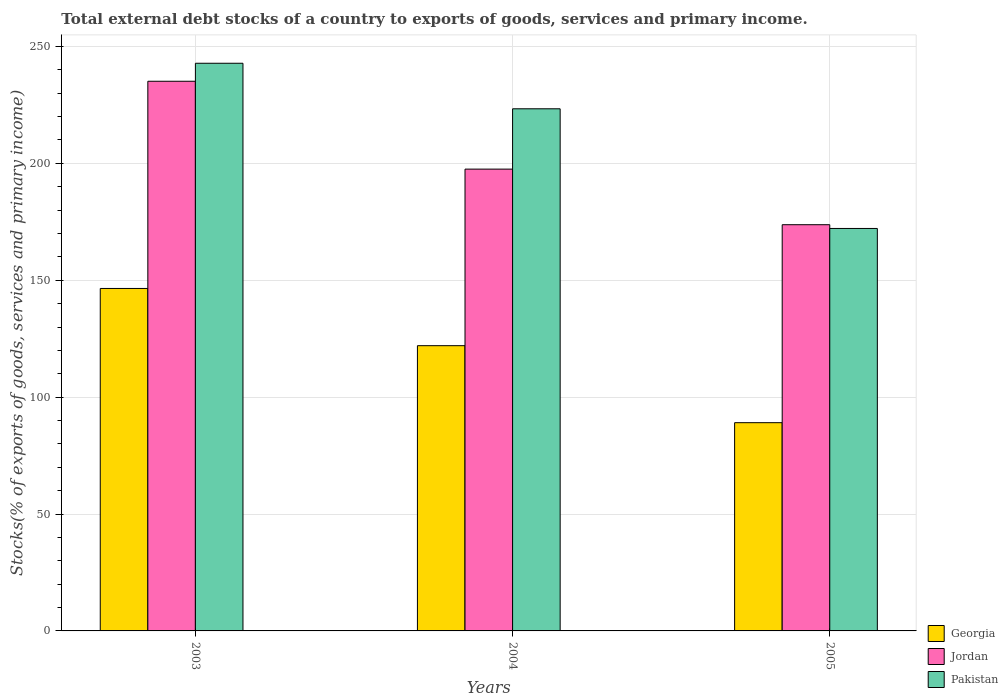How many different coloured bars are there?
Ensure brevity in your answer.  3. How many bars are there on the 1st tick from the right?
Ensure brevity in your answer.  3. What is the label of the 2nd group of bars from the left?
Your response must be concise. 2004. What is the total debt stocks in Georgia in 2003?
Give a very brief answer. 146.49. Across all years, what is the maximum total debt stocks in Jordan?
Your answer should be very brief. 235.12. Across all years, what is the minimum total debt stocks in Georgia?
Your answer should be very brief. 89.07. In which year was the total debt stocks in Pakistan maximum?
Make the answer very short. 2003. In which year was the total debt stocks in Pakistan minimum?
Give a very brief answer. 2005. What is the total total debt stocks in Georgia in the graph?
Your answer should be very brief. 357.58. What is the difference between the total debt stocks in Jordan in 2003 and that in 2005?
Your answer should be very brief. 61.36. What is the difference between the total debt stocks in Pakistan in 2005 and the total debt stocks in Jordan in 2004?
Keep it short and to the point. -25.38. What is the average total debt stocks in Pakistan per year?
Provide a short and direct response. 212.77. In the year 2003, what is the difference between the total debt stocks in Jordan and total debt stocks in Pakistan?
Provide a short and direct response. -7.7. What is the ratio of the total debt stocks in Jordan in 2003 to that in 2004?
Give a very brief answer. 1.19. Is the total debt stocks in Georgia in 2004 less than that in 2005?
Offer a very short reply. No. Is the difference between the total debt stocks in Jordan in 2003 and 2004 greater than the difference between the total debt stocks in Pakistan in 2003 and 2004?
Your answer should be compact. Yes. What is the difference between the highest and the second highest total debt stocks in Georgia?
Ensure brevity in your answer.  24.47. What is the difference between the highest and the lowest total debt stocks in Georgia?
Offer a terse response. 57.42. In how many years, is the total debt stocks in Jordan greater than the average total debt stocks in Jordan taken over all years?
Your response must be concise. 1. What does the 2nd bar from the left in 2003 represents?
Your answer should be very brief. Jordan. What does the 2nd bar from the right in 2004 represents?
Provide a succinct answer. Jordan. Is it the case that in every year, the sum of the total debt stocks in Georgia and total debt stocks in Jordan is greater than the total debt stocks in Pakistan?
Offer a very short reply. Yes. How many bars are there?
Offer a terse response. 9. Are all the bars in the graph horizontal?
Give a very brief answer. No. How many years are there in the graph?
Provide a short and direct response. 3. Does the graph contain grids?
Your answer should be compact. Yes. Where does the legend appear in the graph?
Offer a very short reply. Bottom right. How many legend labels are there?
Provide a succinct answer. 3. What is the title of the graph?
Ensure brevity in your answer.  Total external debt stocks of a country to exports of goods, services and primary income. What is the label or title of the Y-axis?
Your answer should be compact. Stocks(% of exports of goods, services and primary income). What is the Stocks(% of exports of goods, services and primary income) of Georgia in 2003?
Provide a short and direct response. 146.49. What is the Stocks(% of exports of goods, services and primary income) in Jordan in 2003?
Your response must be concise. 235.12. What is the Stocks(% of exports of goods, services and primary income) in Pakistan in 2003?
Offer a terse response. 242.82. What is the Stocks(% of exports of goods, services and primary income) in Georgia in 2004?
Keep it short and to the point. 122.02. What is the Stocks(% of exports of goods, services and primary income) of Jordan in 2004?
Your answer should be compact. 197.54. What is the Stocks(% of exports of goods, services and primary income) of Pakistan in 2004?
Offer a terse response. 223.34. What is the Stocks(% of exports of goods, services and primary income) in Georgia in 2005?
Ensure brevity in your answer.  89.07. What is the Stocks(% of exports of goods, services and primary income) of Jordan in 2005?
Ensure brevity in your answer.  173.76. What is the Stocks(% of exports of goods, services and primary income) of Pakistan in 2005?
Your answer should be very brief. 172.16. Across all years, what is the maximum Stocks(% of exports of goods, services and primary income) in Georgia?
Your response must be concise. 146.49. Across all years, what is the maximum Stocks(% of exports of goods, services and primary income) of Jordan?
Offer a terse response. 235.12. Across all years, what is the maximum Stocks(% of exports of goods, services and primary income) of Pakistan?
Provide a short and direct response. 242.82. Across all years, what is the minimum Stocks(% of exports of goods, services and primary income) in Georgia?
Keep it short and to the point. 89.07. Across all years, what is the minimum Stocks(% of exports of goods, services and primary income) of Jordan?
Offer a very short reply. 173.76. Across all years, what is the minimum Stocks(% of exports of goods, services and primary income) of Pakistan?
Offer a terse response. 172.16. What is the total Stocks(% of exports of goods, services and primary income) of Georgia in the graph?
Provide a succinct answer. 357.58. What is the total Stocks(% of exports of goods, services and primary income) of Jordan in the graph?
Offer a very short reply. 606.41. What is the total Stocks(% of exports of goods, services and primary income) in Pakistan in the graph?
Offer a very short reply. 638.32. What is the difference between the Stocks(% of exports of goods, services and primary income) in Georgia in 2003 and that in 2004?
Provide a short and direct response. 24.47. What is the difference between the Stocks(% of exports of goods, services and primary income) in Jordan in 2003 and that in 2004?
Your response must be concise. 37.58. What is the difference between the Stocks(% of exports of goods, services and primary income) in Pakistan in 2003 and that in 2004?
Your answer should be very brief. 19.48. What is the difference between the Stocks(% of exports of goods, services and primary income) in Georgia in 2003 and that in 2005?
Give a very brief answer. 57.42. What is the difference between the Stocks(% of exports of goods, services and primary income) in Jordan in 2003 and that in 2005?
Your response must be concise. 61.36. What is the difference between the Stocks(% of exports of goods, services and primary income) of Pakistan in 2003 and that in 2005?
Your answer should be compact. 70.66. What is the difference between the Stocks(% of exports of goods, services and primary income) in Georgia in 2004 and that in 2005?
Your answer should be very brief. 32.94. What is the difference between the Stocks(% of exports of goods, services and primary income) in Jordan in 2004 and that in 2005?
Your answer should be very brief. 23.78. What is the difference between the Stocks(% of exports of goods, services and primary income) in Pakistan in 2004 and that in 2005?
Your response must be concise. 51.19. What is the difference between the Stocks(% of exports of goods, services and primary income) in Georgia in 2003 and the Stocks(% of exports of goods, services and primary income) in Jordan in 2004?
Provide a short and direct response. -51.05. What is the difference between the Stocks(% of exports of goods, services and primary income) in Georgia in 2003 and the Stocks(% of exports of goods, services and primary income) in Pakistan in 2004?
Provide a short and direct response. -76.86. What is the difference between the Stocks(% of exports of goods, services and primary income) in Jordan in 2003 and the Stocks(% of exports of goods, services and primary income) in Pakistan in 2004?
Give a very brief answer. 11.77. What is the difference between the Stocks(% of exports of goods, services and primary income) of Georgia in 2003 and the Stocks(% of exports of goods, services and primary income) of Jordan in 2005?
Keep it short and to the point. -27.27. What is the difference between the Stocks(% of exports of goods, services and primary income) of Georgia in 2003 and the Stocks(% of exports of goods, services and primary income) of Pakistan in 2005?
Offer a terse response. -25.67. What is the difference between the Stocks(% of exports of goods, services and primary income) of Jordan in 2003 and the Stocks(% of exports of goods, services and primary income) of Pakistan in 2005?
Offer a terse response. 62.96. What is the difference between the Stocks(% of exports of goods, services and primary income) in Georgia in 2004 and the Stocks(% of exports of goods, services and primary income) in Jordan in 2005?
Your response must be concise. -51.74. What is the difference between the Stocks(% of exports of goods, services and primary income) in Georgia in 2004 and the Stocks(% of exports of goods, services and primary income) in Pakistan in 2005?
Ensure brevity in your answer.  -50.14. What is the difference between the Stocks(% of exports of goods, services and primary income) of Jordan in 2004 and the Stocks(% of exports of goods, services and primary income) of Pakistan in 2005?
Offer a terse response. 25.38. What is the average Stocks(% of exports of goods, services and primary income) of Georgia per year?
Provide a short and direct response. 119.19. What is the average Stocks(% of exports of goods, services and primary income) in Jordan per year?
Your response must be concise. 202.14. What is the average Stocks(% of exports of goods, services and primary income) in Pakistan per year?
Give a very brief answer. 212.77. In the year 2003, what is the difference between the Stocks(% of exports of goods, services and primary income) in Georgia and Stocks(% of exports of goods, services and primary income) in Jordan?
Keep it short and to the point. -88.63. In the year 2003, what is the difference between the Stocks(% of exports of goods, services and primary income) in Georgia and Stocks(% of exports of goods, services and primary income) in Pakistan?
Make the answer very short. -96.33. In the year 2003, what is the difference between the Stocks(% of exports of goods, services and primary income) in Jordan and Stocks(% of exports of goods, services and primary income) in Pakistan?
Offer a terse response. -7.7. In the year 2004, what is the difference between the Stocks(% of exports of goods, services and primary income) in Georgia and Stocks(% of exports of goods, services and primary income) in Jordan?
Provide a succinct answer. -75.52. In the year 2004, what is the difference between the Stocks(% of exports of goods, services and primary income) of Georgia and Stocks(% of exports of goods, services and primary income) of Pakistan?
Provide a succinct answer. -101.33. In the year 2004, what is the difference between the Stocks(% of exports of goods, services and primary income) in Jordan and Stocks(% of exports of goods, services and primary income) in Pakistan?
Offer a very short reply. -25.81. In the year 2005, what is the difference between the Stocks(% of exports of goods, services and primary income) of Georgia and Stocks(% of exports of goods, services and primary income) of Jordan?
Offer a very short reply. -84.68. In the year 2005, what is the difference between the Stocks(% of exports of goods, services and primary income) of Georgia and Stocks(% of exports of goods, services and primary income) of Pakistan?
Give a very brief answer. -83.08. In the year 2005, what is the difference between the Stocks(% of exports of goods, services and primary income) in Jordan and Stocks(% of exports of goods, services and primary income) in Pakistan?
Your answer should be very brief. 1.6. What is the ratio of the Stocks(% of exports of goods, services and primary income) in Georgia in 2003 to that in 2004?
Offer a terse response. 1.2. What is the ratio of the Stocks(% of exports of goods, services and primary income) in Jordan in 2003 to that in 2004?
Provide a succinct answer. 1.19. What is the ratio of the Stocks(% of exports of goods, services and primary income) of Pakistan in 2003 to that in 2004?
Your answer should be compact. 1.09. What is the ratio of the Stocks(% of exports of goods, services and primary income) in Georgia in 2003 to that in 2005?
Provide a succinct answer. 1.64. What is the ratio of the Stocks(% of exports of goods, services and primary income) of Jordan in 2003 to that in 2005?
Your response must be concise. 1.35. What is the ratio of the Stocks(% of exports of goods, services and primary income) of Pakistan in 2003 to that in 2005?
Offer a terse response. 1.41. What is the ratio of the Stocks(% of exports of goods, services and primary income) of Georgia in 2004 to that in 2005?
Offer a very short reply. 1.37. What is the ratio of the Stocks(% of exports of goods, services and primary income) in Jordan in 2004 to that in 2005?
Your answer should be very brief. 1.14. What is the ratio of the Stocks(% of exports of goods, services and primary income) in Pakistan in 2004 to that in 2005?
Provide a short and direct response. 1.3. What is the difference between the highest and the second highest Stocks(% of exports of goods, services and primary income) in Georgia?
Provide a succinct answer. 24.47. What is the difference between the highest and the second highest Stocks(% of exports of goods, services and primary income) in Jordan?
Make the answer very short. 37.58. What is the difference between the highest and the second highest Stocks(% of exports of goods, services and primary income) in Pakistan?
Your response must be concise. 19.48. What is the difference between the highest and the lowest Stocks(% of exports of goods, services and primary income) of Georgia?
Provide a succinct answer. 57.42. What is the difference between the highest and the lowest Stocks(% of exports of goods, services and primary income) in Jordan?
Give a very brief answer. 61.36. What is the difference between the highest and the lowest Stocks(% of exports of goods, services and primary income) in Pakistan?
Give a very brief answer. 70.66. 